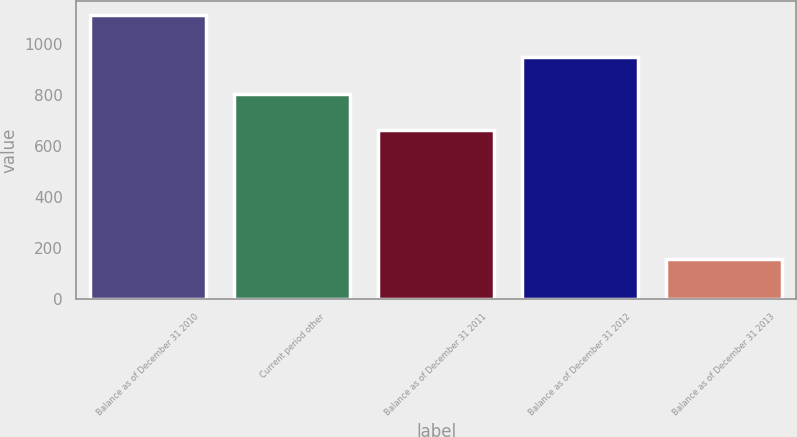<chart> <loc_0><loc_0><loc_500><loc_500><bar_chart><fcel>Balance as of December 31 2010<fcel>Current period other<fcel>Balance as of December 31 2011<fcel>Balance as of December 31 2012<fcel>Balance as of December 31 2013<nl><fcel>1115<fcel>806.4<fcel>663<fcel>949.8<fcel>157<nl></chart> 